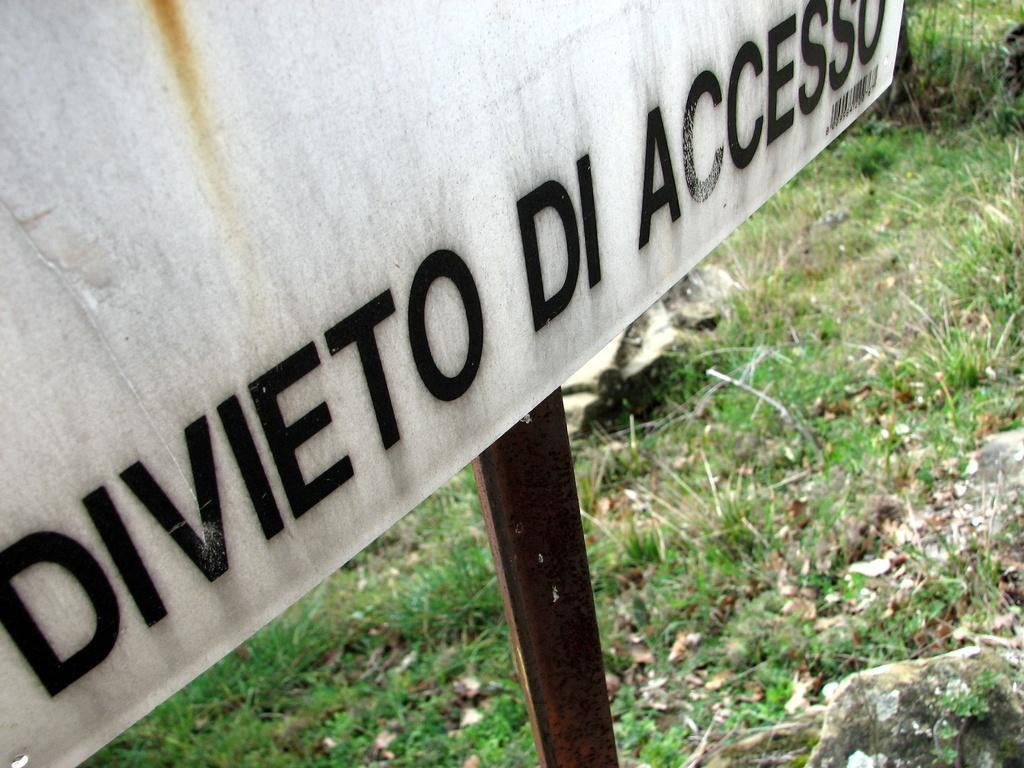What is the main object in the image? There is a white board in the image. How is the white board supported? The board is attached to a metal rod. What type of natural environment is visible at the bottom of the image? Green grass and rocks are visible at the bottom of the image. What type of condition does the chicken have in the image? There is no chicken present in the image. What topic is being discussed on the white board in the image? The image does not show any text or information on the white board, so it is not possible to determine what topic might be discussed. 